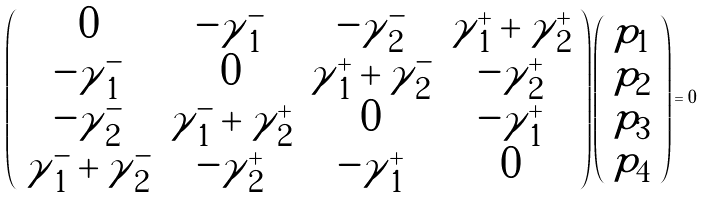<formula> <loc_0><loc_0><loc_500><loc_500>\left ( \begin{array} { c c c c } 0 & - { \tilde { \gamma } } _ { 1 } ^ { - } & - { \tilde { \gamma } } _ { 2 } ^ { - } & { \tilde { \gamma } } _ { 1 } ^ { + } + { \tilde { \gamma } } _ { 2 } ^ { + } \\ - { \tilde { \gamma } } _ { 1 } ^ { - } & 0 & { \tilde { \gamma } } _ { 1 } ^ { + } + { \tilde { \gamma } } _ { 2 } ^ { - } & - { \tilde { \gamma } } _ { 2 } ^ { + } \\ - { \tilde { \gamma } } _ { 2 } ^ { - } & { \tilde { \gamma } } _ { 1 } ^ { - } + { \tilde { \gamma } } _ { 2 } ^ { + } & 0 & - { \tilde { \gamma } } _ { 1 } ^ { + } \\ { \tilde { \gamma } } _ { 1 } ^ { - } + { \tilde { \gamma } } _ { 2 } ^ { - } & - { \tilde { \gamma } } _ { 2 } ^ { + } & - { \tilde { \gamma } } _ { 1 } ^ { + } & 0 \end{array} \right ) \left ( \begin{array} { c } p _ { 1 } \\ p _ { 2 } \\ p _ { 3 } \\ p _ { 4 } \end{array} \right ) = 0</formula> 